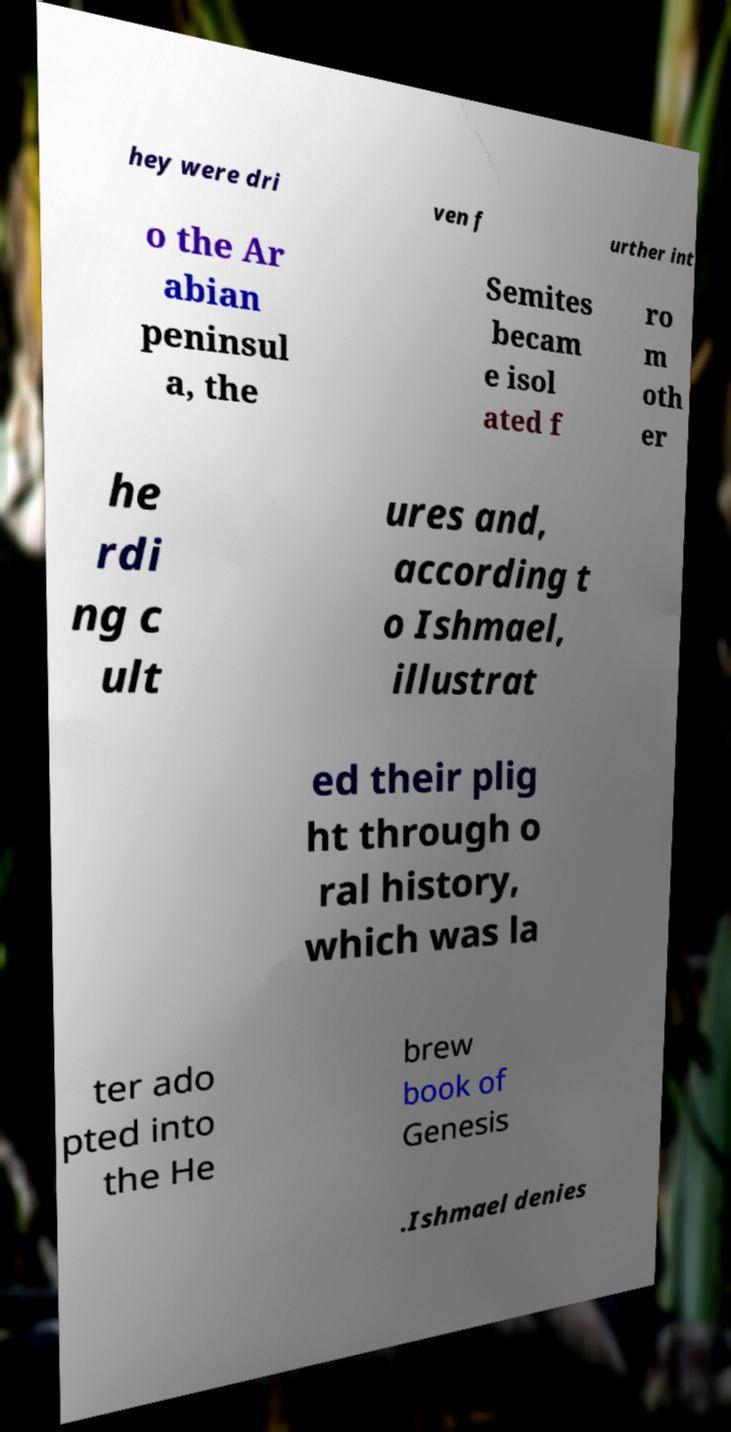Please identify and transcribe the text found in this image. hey were dri ven f urther int o the Ar abian peninsul a, the Semites becam e isol ated f ro m oth er he rdi ng c ult ures and, according t o Ishmael, illustrat ed their plig ht through o ral history, which was la ter ado pted into the He brew book of Genesis .Ishmael denies 